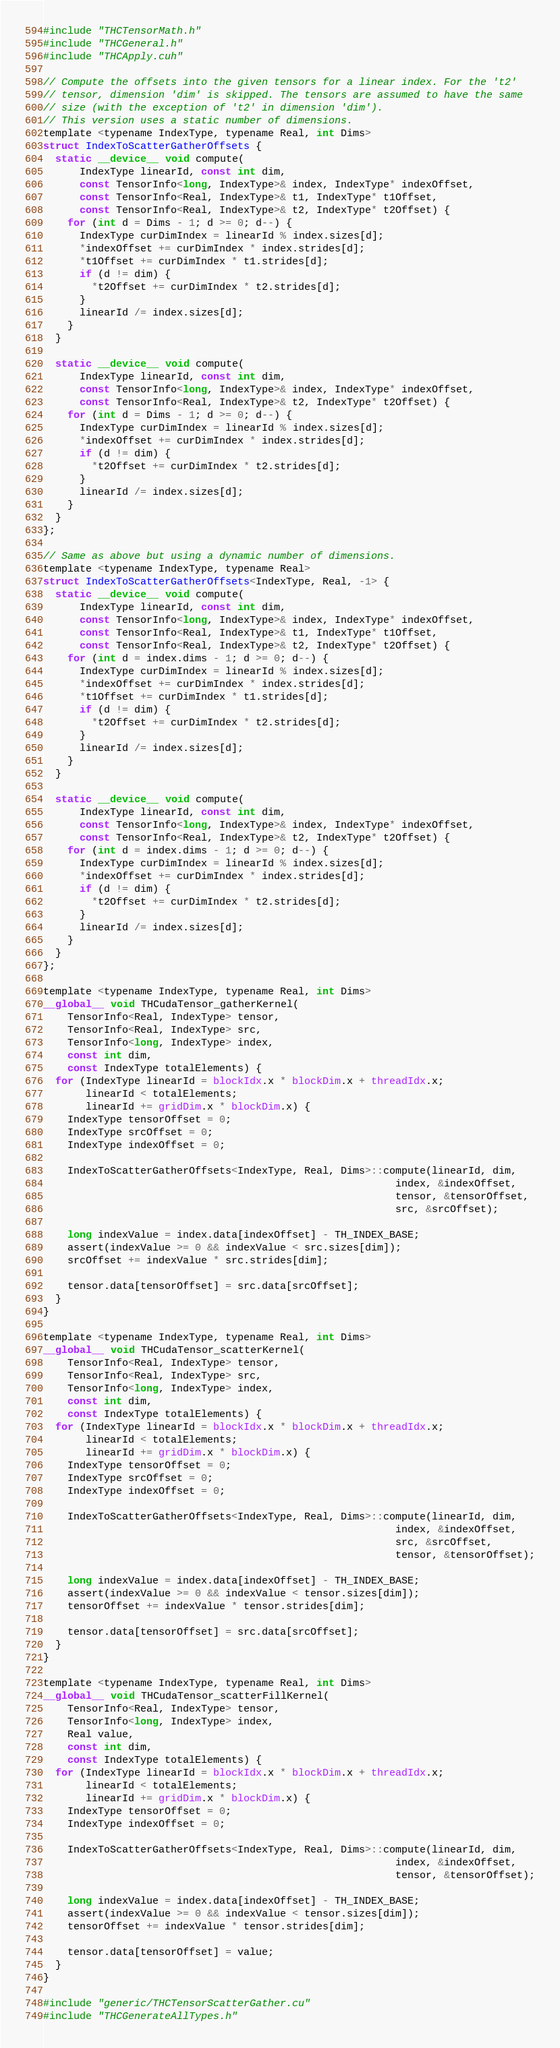Convert code to text. <code><loc_0><loc_0><loc_500><loc_500><_Cuda_>#include "THCTensorMath.h"
#include "THCGeneral.h"
#include "THCApply.cuh"

// Compute the offsets into the given tensors for a linear index. For the 't2'
// tensor, dimension 'dim' is skipped. The tensors are assumed to have the same
// size (with the exception of 't2' in dimension 'dim').
// This version uses a static number of dimensions.
template <typename IndexType, typename Real, int Dims>
struct IndexToScatterGatherOffsets {
  static __device__ void compute(
      IndexType linearId, const int dim,
      const TensorInfo<long, IndexType>& index, IndexType* indexOffset,
      const TensorInfo<Real, IndexType>& t1, IndexType* t1Offset,
      const TensorInfo<Real, IndexType>& t2, IndexType* t2Offset) {
    for (int d = Dims - 1; d >= 0; d--) {
      IndexType curDimIndex = linearId % index.sizes[d];
      *indexOffset += curDimIndex * index.strides[d];
      *t1Offset += curDimIndex * t1.strides[d];
      if (d != dim) {
        *t2Offset += curDimIndex * t2.strides[d];
      }
      linearId /= index.sizes[d];
    }
  }

  static __device__ void compute(
      IndexType linearId, const int dim,
      const TensorInfo<long, IndexType>& index, IndexType* indexOffset,
      const TensorInfo<Real, IndexType>& t2, IndexType* t2Offset) {
    for (int d = Dims - 1; d >= 0; d--) {
      IndexType curDimIndex = linearId % index.sizes[d];
      *indexOffset += curDimIndex * index.strides[d];
      if (d != dim) {
        *t2Offset += curDimIndex * t2.strides[d];
      }
      linearId /= index.sizes[d];
    }
  }
};

// Same as above but using a dynamic number of dimensions.
template <typename IndexType, typename Real>
struct IndexToScatterGatherOffsets<IndexType, Real, -1> {
  static __device__ void compute(
      IndexType linearId, const int dim,
      const TensorInfo<long, IndexType>& index, IndexType* indexOffset,
      const TensorInfo<Real, IndexType>& t1, IndexType* t1Offset,
      const TensorInfo<Real, IndexType>& t2, IndexType* t2Offset) {
    for (int d = index.dims - 1; d >= 0; d--) {
      IndexType curDimIndex = linearId % index.sizes[d];
      *indexOffset += curDimIndex * index.strides[d];
      *t1Offset += curDimIndex * t1.strides[d];
      if (d != dim) {
        *t2Offset += curDimIndex * t2.strides[d];
      }
      linearId /= index.sizes[d];
    }
  }

  static __device__ void compute(
      IndexType linearId, const int dim,
      const TensorInfo<long, IndexType>& index, IndexType* indexOffset,
      const TensorInfo<Real, IndexType>& t2, IndexType* t2Offset) {
    for (int d = index.dims - 1; d >= 0; d--) {
      IndexType curDimIndex = linearId % index.sizes[d];
      *indexOffset += curDimIndex * index.strides[d];
      if (d != dim) {
        *t2Offset += curDimIndex * t2.strides[d];
      }
      linearId /= index.sizes[d];
    }
  }
};

template <typename IndexType, typename Real, int Dims>
__global__ void THCudaTensor_gatherKernel(
    TensorInfo<Real, IndexType> tensor,
    TensorInfo<Real, IndexType> src,
    TensorInfo<long, IndexType> index,
    const int dim,
    const IndexType totalElements) {
  for (IndexType linearId = blockIdx.x * blockDim.x + threadIdx.x;
       linearId < totalElements;
       linearId += gridDim.x * blockDim.x) {
    IndexType tensorOffset = 0;
    IndexType srcOffset = 0;
    IndexType indexOffset = 0;

    IndexToScatterGatherOffsets<IndexType, Real, Dims>::compute(linearId, dim,
                                                          index, &indexOffset,
                                                          tensor, &tensorOffset,
                                                          src, &srcOffset);

    long indexValue = index.data[indexOffset] - TH_INDEX_BASE;
    assert(indexValue >= 0 && indexValue < src.sizes[dim]);
    srcOffset += indexValue * src.strides[dim];

    tensor.data[tensorOffset] = src.data[srcOffset];
  }
}

template <typename IndexType, typename Real, int Dims>
__global__ void THCudaTensor_scatterKernel(
    TensorInfo<Real, IndexType> tensor,
    TensorInfo<Real, IndexType> src,
    TensorInfo<long, IndexType> index,
    const int dim,
    const IndexType totalElements) {
  for (IndexType linearId = blockIdx.x * blockDim.x + threadIdx.x;
       linearId < totalElements;
       linearId += gridDim.x * blockDim.x) {
    IndexType tensorOffset = 0;
    IndexType srcOffset = 0;
    IndexType indexOffset = 0;

    IndexToScatterGatherOffsets<IndexType, Real, Dims>::compute(linearId, dim,
                                                          index, &indexOffset,
                                                          src, &srcOffset,
                                                          tensor, &tensorOffset);

    long indexValue = index.data[indexOffset] - TH_INDEX_BASE;
    assert(indexValue >= 0 && indexValue < tensor.sizes[dim]);
    tensorOffset += indexValue * tensor.strides[dim];

    tensor.data[tensorOffset] = src.data[srcOffset];
  }
}

template <typename IndexType, typename Real, int Dims>
__global__ void THCudaTensor_scatterFillKernel(
    TensorInfo<Real, IndexType> tensor,
    TensorInfo<long, IndexType> index,
    Real value,
    const int dim,
    const IndexType totalElements) {
  for (IndexType linearId = blockIdx.x * blockDim.x + threadIdx.x;
       linearId < totalElements;
       linearId += gridDim.x * blockDim.x) {
    IndexType tensorOffset = 0;
    IndexType indexOffset = 0;

    IndexToScatterGatherOffsets<IndexType, Real, Dims>::compute(linearId, dim,
                                                          index, &indexOffset,
                                                          tensor, &tensorOffset);

    long indexValue = index.data[indexOffset] - TH_INDEX_BASE;
    assert(indexValue >= 0 && indexValue < tensor.sizes[dim]);
    tensorOffset += indexValue * tensor.strides[dim];

    tensor.data[tensorOffset] = value;
  }
}

#include "generic/THCTensorScatterGather.cu"
#include "THCGenerateAllTypes.h"
</code> 